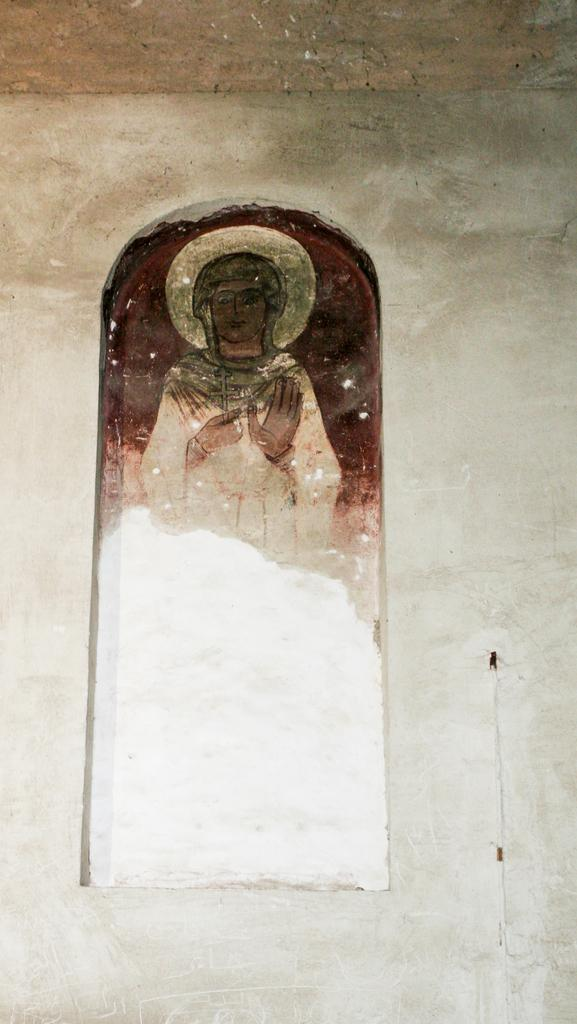What is present on the wall in the image? There is an art piece on the wall in the image. Can you describe the art piece? Unfortunately, the description of the art piece is not provided in the facts. What type of wall is visible in the image? The facts only mention that there is a wall in the image, without specifying its type or material. How much money is depicted in the art piece on the wall? There is no mention of money or any financial elements in the image or the art piece. 